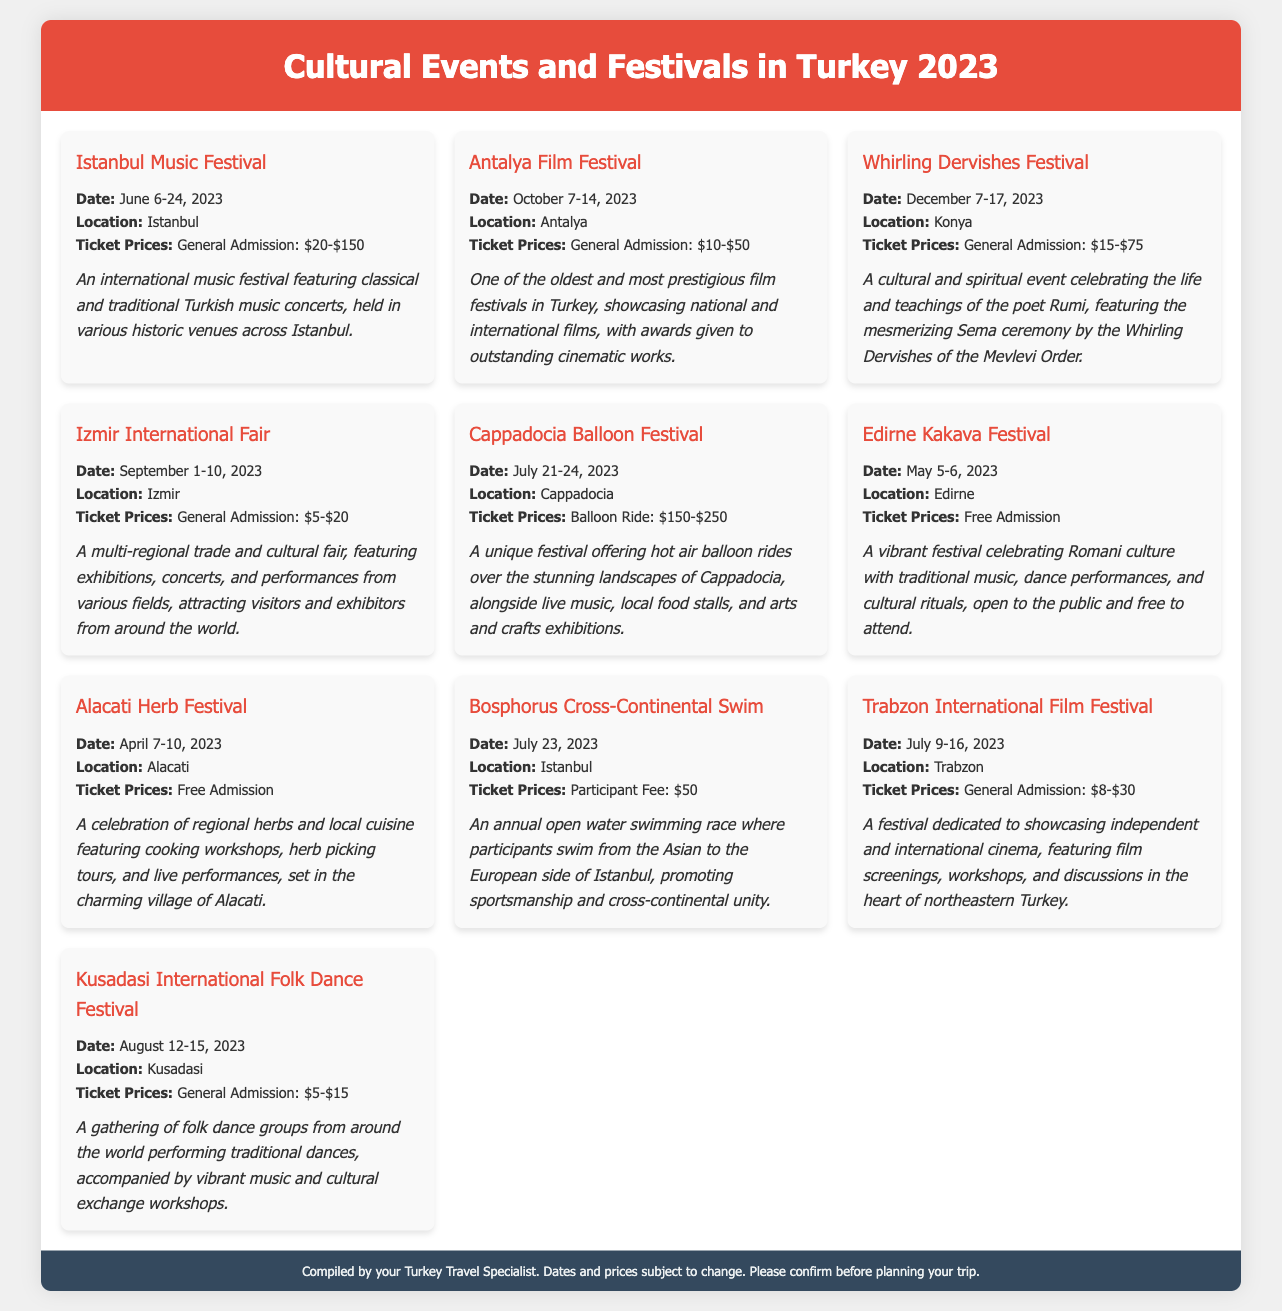What is the date of the Istanbul Music Festival? The Istanbul Music Festival takes place from June 6 to June 24, 2023.
Answer: June 6-24, 2023 Where is the Antalya Film Festival held? The Antalya Film Festival is located in Antalya.
Answer: Antalya What is the ticket price range for the Whirling Dervishes Festival? The ticket prices for the Whirling Dervishes Festival range from $15 to $75.
Answer: $15-$75 Which festival offers free admission? Both the Edirne Kakava Festival and the Alacati Herb Festival offer free admission.
Answer: Edirne Kakava Festival, Alacati Herb Festival What type of event is the Bosphorus Cross-Continental Swim? The Bosphorus Cross-Continental Swim is an open water swimming race.
Answer: Open water swimming race How many days does the Izmir International Fair last? The Izmir International Fair lasts for 10 days.
Answer: 10 days Who is the festival dedicated to during the Whirling Dervishes Festival? The festival celebrates the life and teachings of the poet Rumi.
Answer: Rumi What is the location of the Cappadocia Balloon Festival? The Cappadocia Balloon Festival is held in Cappadocia.
Answer: Cappadocia What type of performance is featured at the Kusadasi International Folk Dance Festival? The festival features traditional dances performed by folk dance groups.
Answer: Traditional dances 